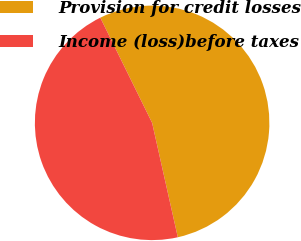Convert chart to OTSL. <chart><loc_0><loc_0><loc_500><loc_500><pie_chart><fcel>Provision for credit losses<fcel>Income (loss)before taxes<nl><fcel>53.77%<fcel>46.23%<nl></chart> 